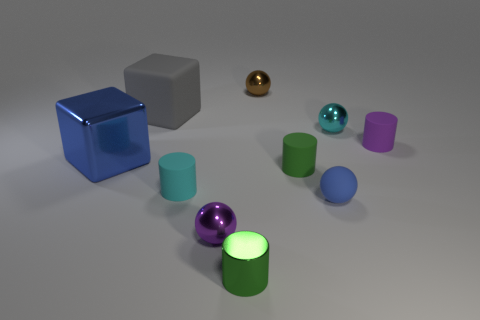There is a brown ball that is the same size as the purple matte cylinder; what is it made of?
Offer a terse response. Metal. There is a thing behind the gray rubber thing; is it the same size as the cyan thing to the right of the brown ball?
Give a very brief answer. Yes. How many things are either small blue matte balls or small green cylinders in front of the small blue thing?
Your answer should be very brief. 2. Is there a large brown shiny thing that has the same shape as the purple rubber object?
Offer a very short reply. No. There is a green cylinder right of the small brown metallic thing to the left of the rubber ball; what size is it?
Provide a short and direct response. Small. Do the large metallic cube and the big rubber block have the same color?
Your response must be concise. No. What number of rubber objects are either cyan spheres or large cubes?
Your answer should be very brief. 1. How many brown objects are there?
Your answer should be compact. 1. Do the blue object that is left of the brown metal object and the small green cylinder that is behind the metallic cylinder have the same material?
Offer a very short reply. No. There is a tiny metal thing that is the same shape as the small cyan matte object; what is its color?
Give a very brief answer. Green. 